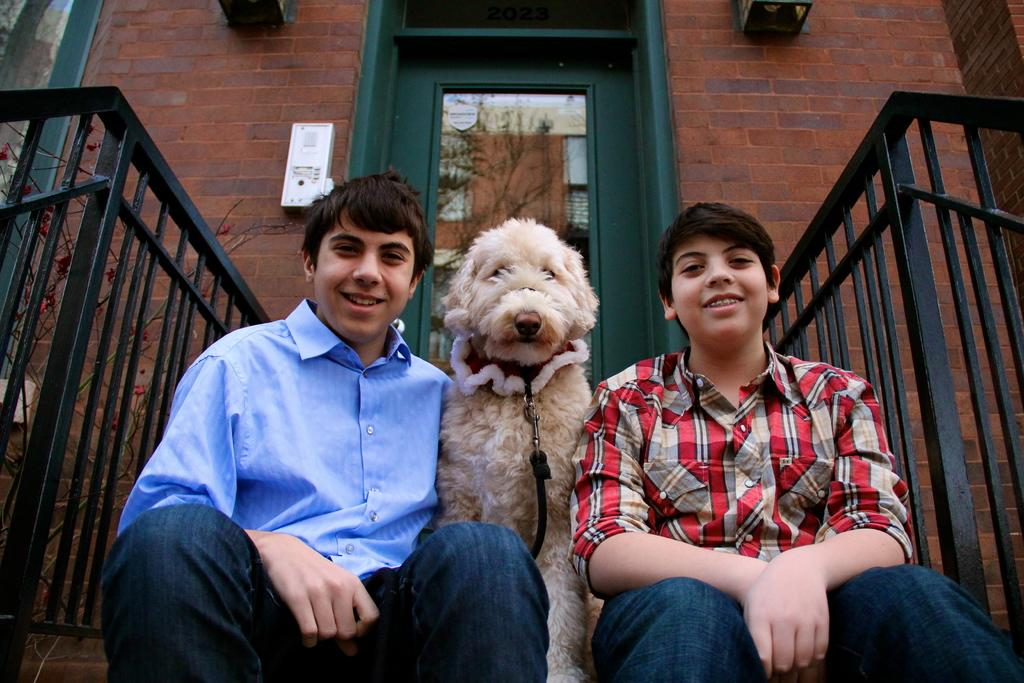How many boys are in the image? There are two boys in the image. What are the boys doing in the image? The boys are sitting between a dog. Can you describe any architectural features in the image? Yes, there is a door in the image. What type of vegetation is present in the image? There is a plant in the image. What type of background is visible in the image? There is a brick wall in the image. What type of apple is the boy holding in the image? There is no apple present in the image. What color is the point on the shirt of the boy on the left? There is no mention of a point on the shirt of the boy on the left in the provided facts. 